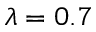<formula> <loc_0><loc_0><loc_500><loc_500>\lambda = 0 . 7</formula> 